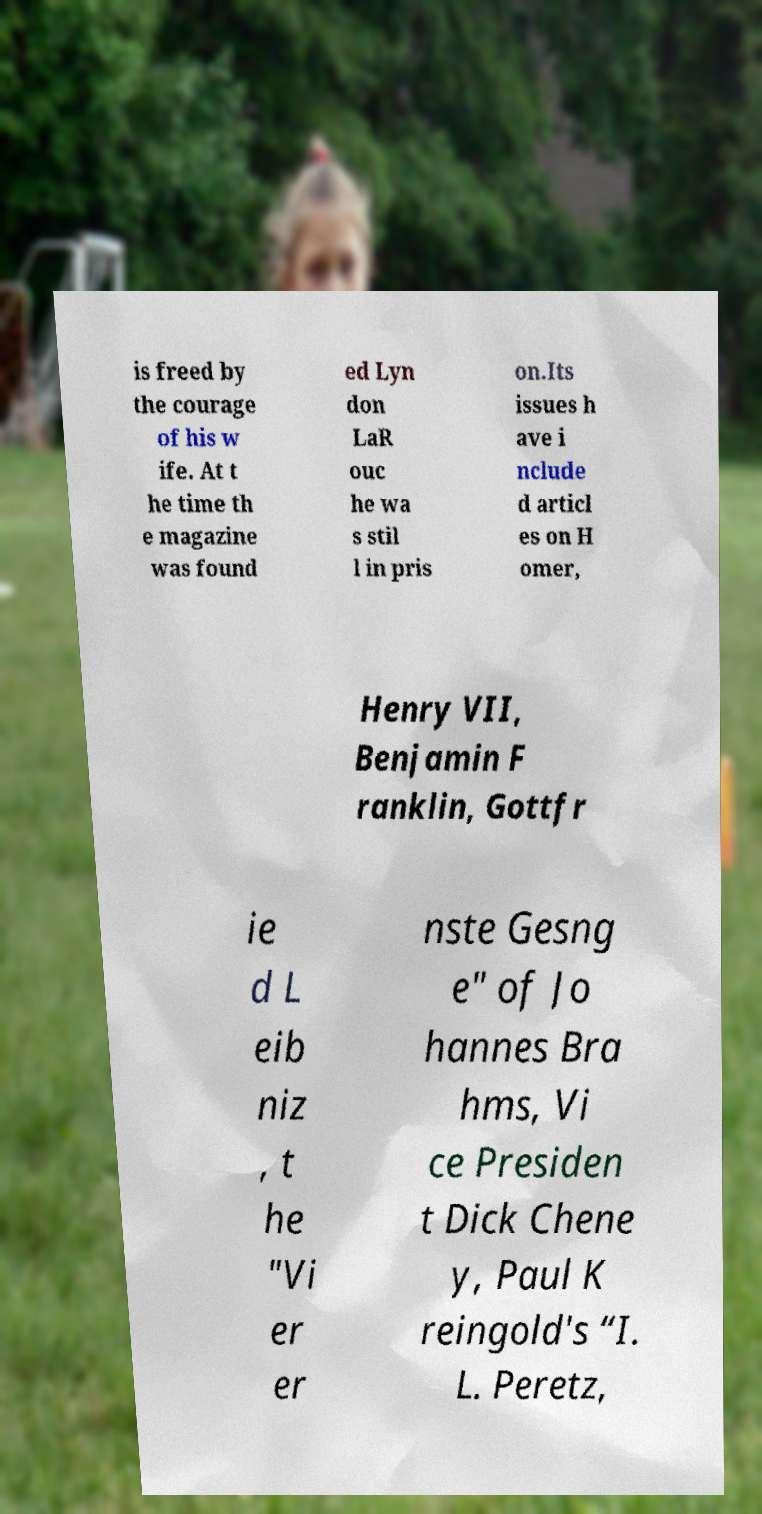What messages or text are displayed in this image? I need them in a readable, typed format. is freed by the courage of his w ife. At t he time th e magazine was found ed Lyn don LaR ouc he wa s stil l in pris on.Its issues h ave i nclude d articl es on H omer, Henry VII, Benjamin F ranklin, Gottfr ie d L eib niz , t he "Vi er er nste Gesng e" of Jo hannes Bra hms, Vi ce Presiden t Dick Chene y, Paul K reingold's “I. L. Peretz, 